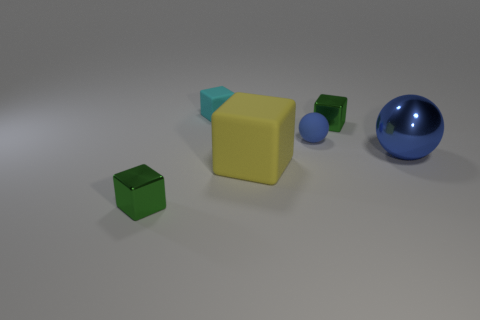Is the size of the matte ball the same as the matte thing in front of the big metal sphere? The size of the matte blue ball is noticeably larger than the matte yellow cube in the foreground. Both have a non-reflective surface, but you can tell the difference in size by comparing their dimensions relative to the big metal sphere behind them. 